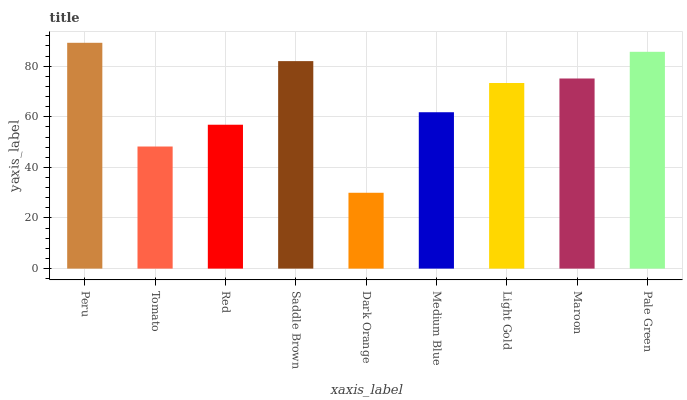Is Dark Orange the minimum?
Answer yes or no. Yes. Is Peru the maximum?
Answer yes or no. Yes. Is Tomato the minimum?
Answer yes or no. No. Is Tomato the maximum?
Answer yes or no. No. Is Peru greater than Tomato?
Answer yes or no. Yes. Is Tomato less than Peru?
Answer yes or no. Yes. Is Tomato greater than Peru?
Answer yes or no. No. Is Peru less than Tomato?
Answer yes or no. No. Is Light Gold the high median?
Answer yes or no. Yes. Is Light Gold the low median?
Answer yes or no. Yes. Is Pale Green the high median?
Answer yes or no. No. Is Tomato the low median?
Answer yes or no. No. 